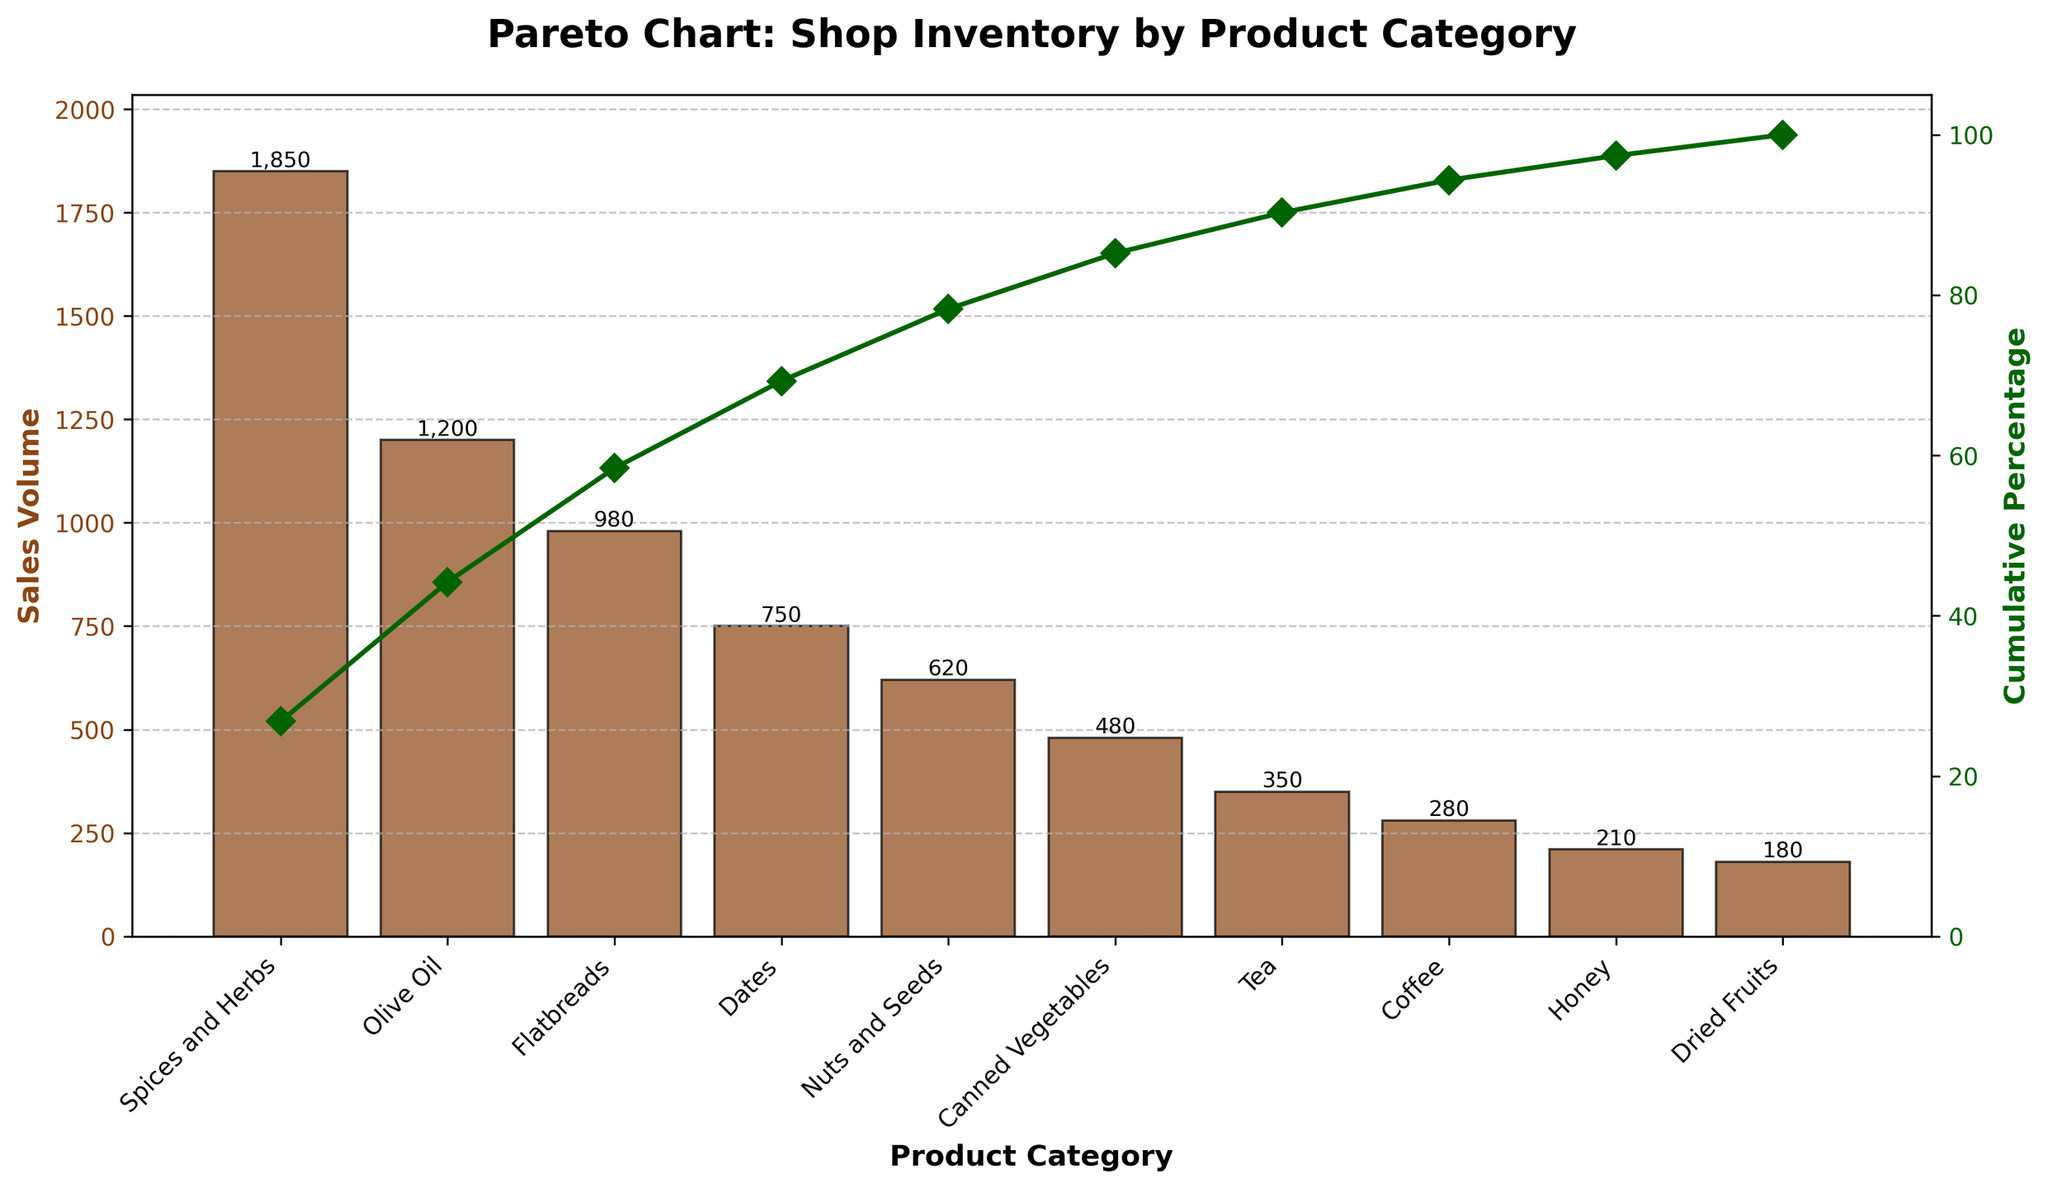How many product categories are represented in the chart? Count the number of distinct bars on the x-axis to identify the number of product categories.
Answer: 10 What is the title of the chart? The title is displayed at the top of the chart.
Answer: Pareto Chart: Shop Inventory by Product Category Which product category has the highest sales volume? Identify the tallest bar in the bar chart.
Answer: Spices and Herbs What is the cumulative percentage for 'Nuts and Seeds'? Locate the point on the cumulative percentage line corresponding to 'Nuts and Seeds' and read its value.
Answer: 85% How much more is the sales volume of 'Spices and Herbs' compared to 'Olive Oil'? Find the heights of the bars for 'Spices and Herbs' and 'Olive Oil', then calculate the difference (1850 - 1200).
Answer: 650 What percentage of total sales volume do 'Spices and Herbs' and 'Olive Oil' account for? Add the sales volumes of 'Spices and Herbs' and 'Olive Oil' (1850 + 1200), then divide by the total sales volume and multiply by 100.
Answer: 54.66% Which product category contributes least to the sales volume? Identify the shortest bar in the bar chart.
Answer: Dried Fruits What cumulative percentage is achieved by the top three product categories? Sum the individual percentage contributions of the top three categories ('Spices and Herbs', 'Olive Oil', and 'Flatbreads').
Answer: 63.89% How are the sales volumes represented visually in the chart? By the heights of the bars on the primary y-axis.
Answer: Bars What color represents the cumulative percentage line and what symbols are used? Observe the color and symbols used for the line representing cumulative percentage on the secondary y-axis.
Answer: Green line with diamond symbols 